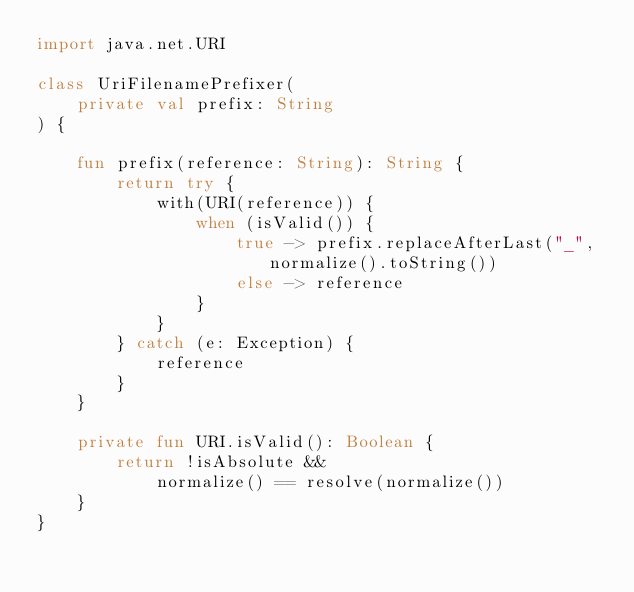<code> <loc_0><loc_0><loc_500><loc_500><_Kotlin_>import java.net.URI

class UriFilenamePrefixer(
    private val prefix: String
) {

    fun prefix(reference: String): String {
        return try {
            with(URI(reference)) {
                when (isValid()) {
                    true -> prefix.replaceAfterLast("_", normalize().toString())
                    else -> reference
                }
            }
        } catch (e: Exception) {
            reference
        }
    }

    private fun URI.isValid(): Boolean {
        return !isAbsolute &&
            normalize() == resolve(normalize())
    }
}
</code> 